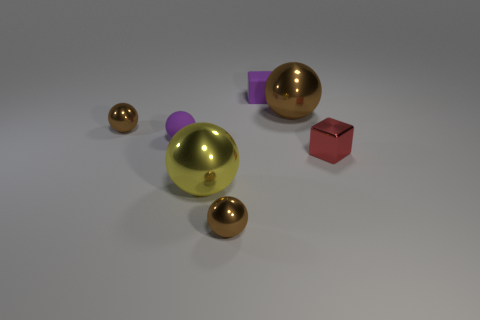Subtract all matte spheres. How many spheres are left? 4 Subtract all brown cylinders. How many brown spheres are left? 3 Subtract all purple spheres. How many spheres are left? 4 Add 1 large blue metallic cylinders. How many objects exist? 8 Subtract 2 balls. How many balls are left? 3 Subtract all spheres. How many objects are left? 2 Subtract 0 cyan blocks. How many objects are left? 7 Subtract all blue blocks. Subtract all yellow spheres. How many blocks are left? 2 Subtract all big metal things. Subtract all red blocks. How many objects are left? 4 Add 6 yellow spheres. How many yellow spheres are left? 7 